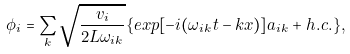<formula> <loc_0><loc_0><loc_500><loc_500>\phi _ { i } = \sum _ { k } \sqrt { \frac { v _ { i } } { 2 L \omega _ { i k } } } \{ e x p [ - i ( \omega _ { i k } t - k x ) ] a _ { i k } + h . c . \} ,</formula> 